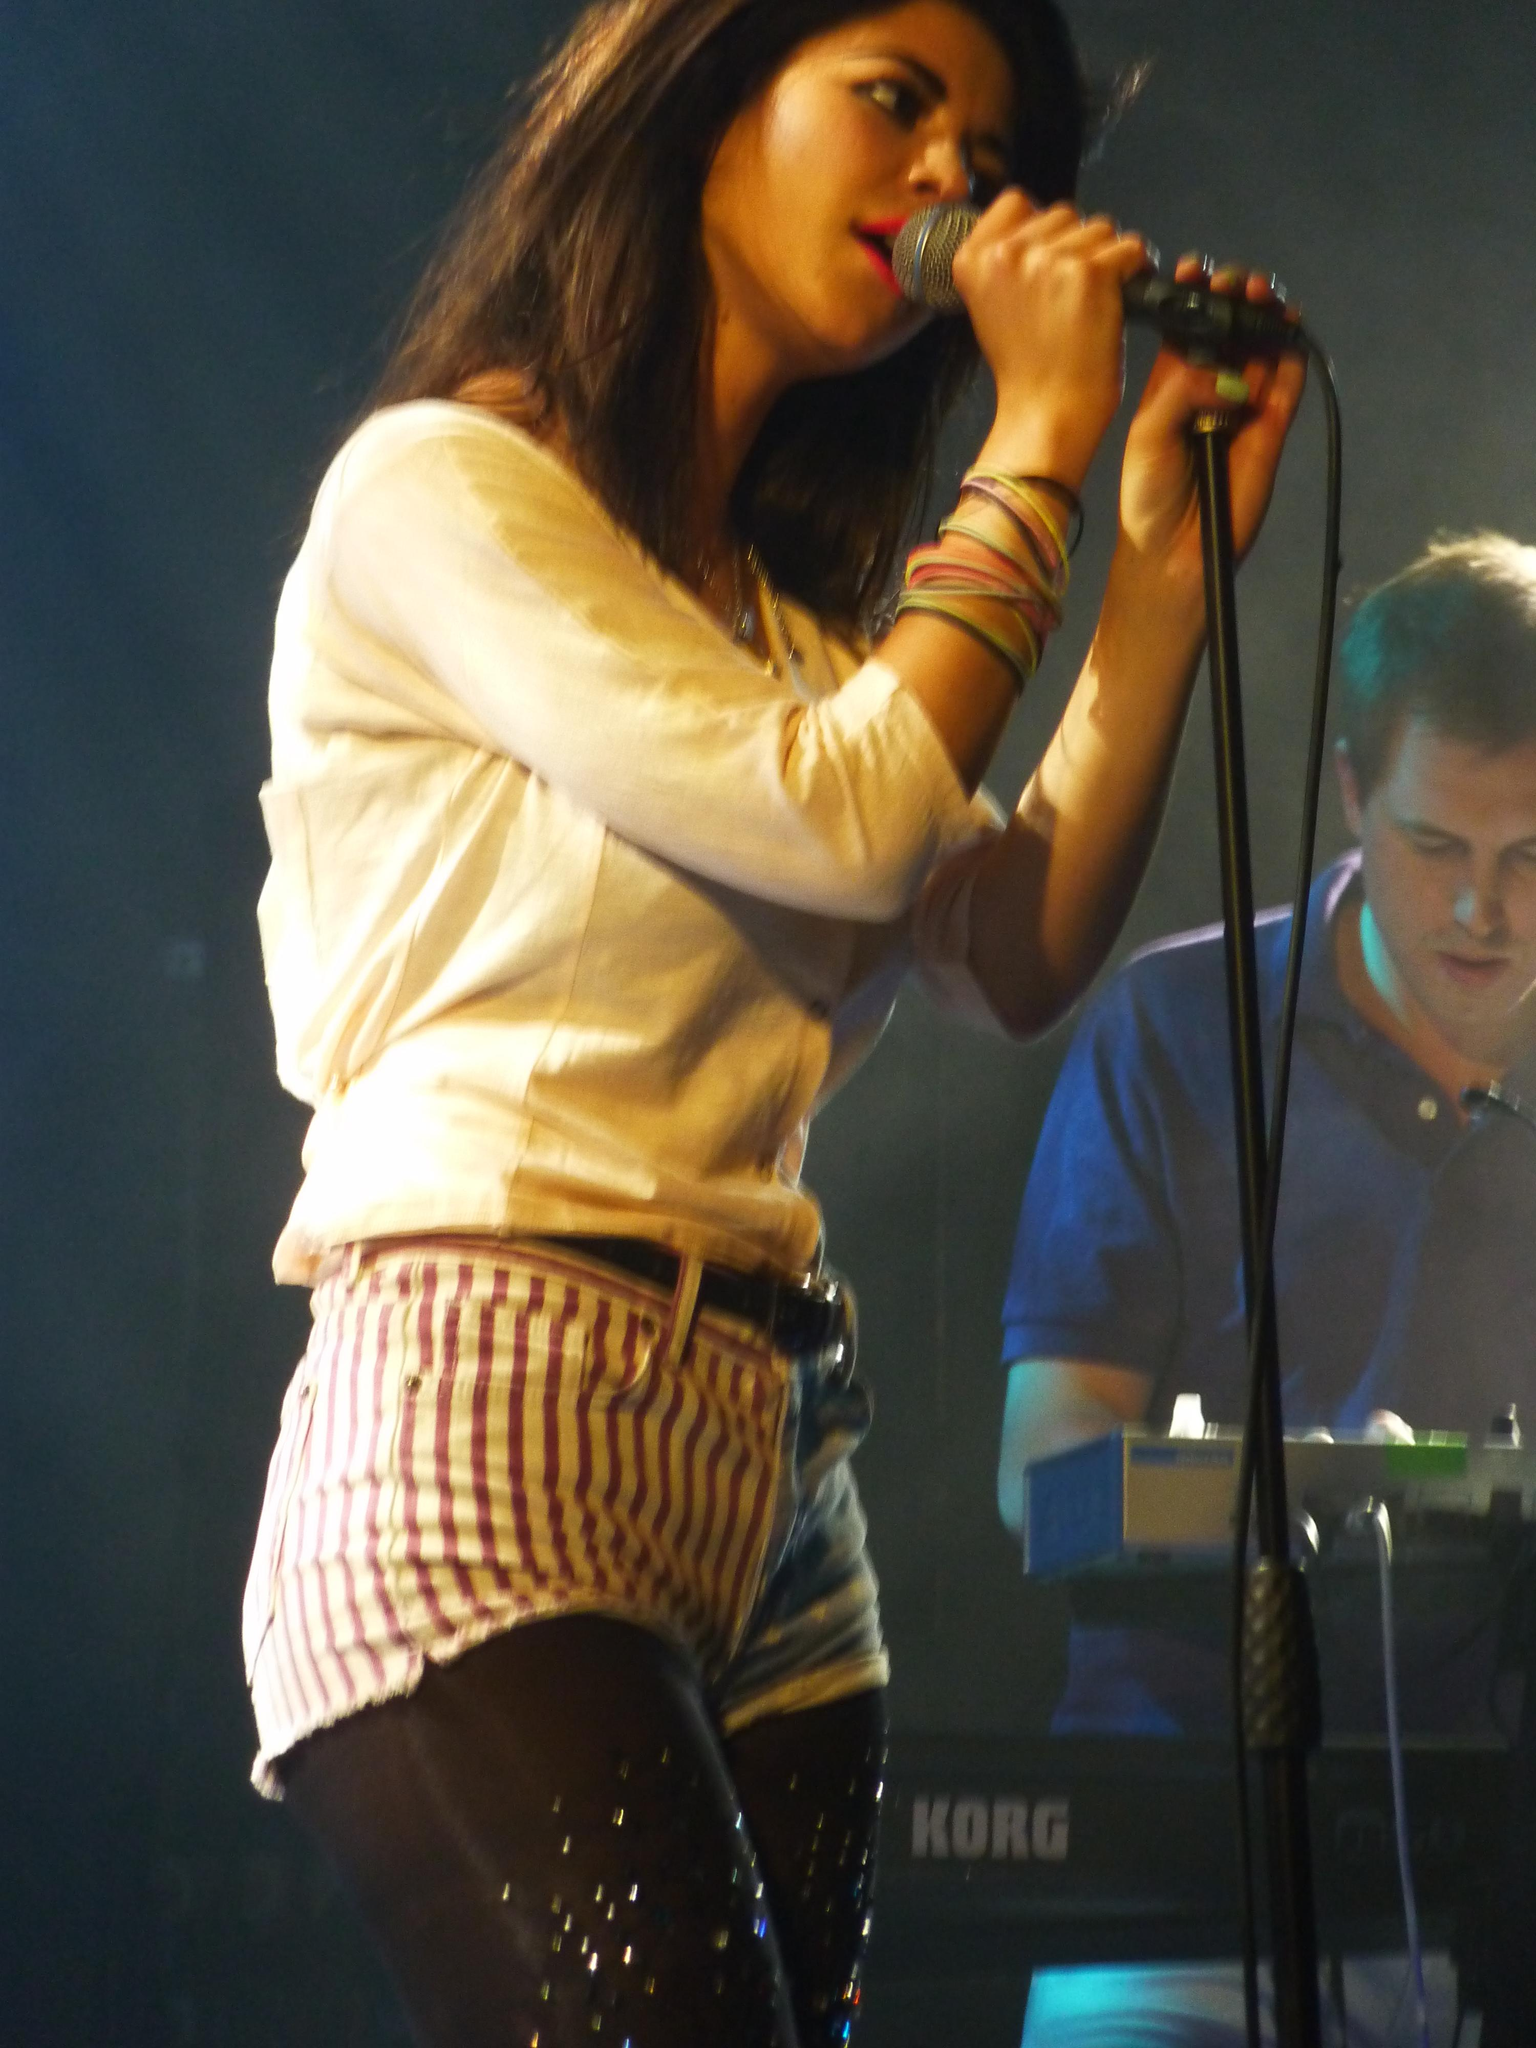Who is the main subject in the image? There is a woman in the image. What is the woman holding in the image? The woman is holding a microphone. What is the woman doing in the image? The woman is singing. Can you describe the other person in the image? There is a person in the image, but their actions or appearance are not specified. What electronic device can be seen in the top right of the image? There is an electronic device in the top right of the image. What type of pot is being used to water the plants in the image? There is no pot or plants present in the image; it features a woman singing with a microphone. How many bulbs are visible in the image? There are no bulbs visible in the image. 